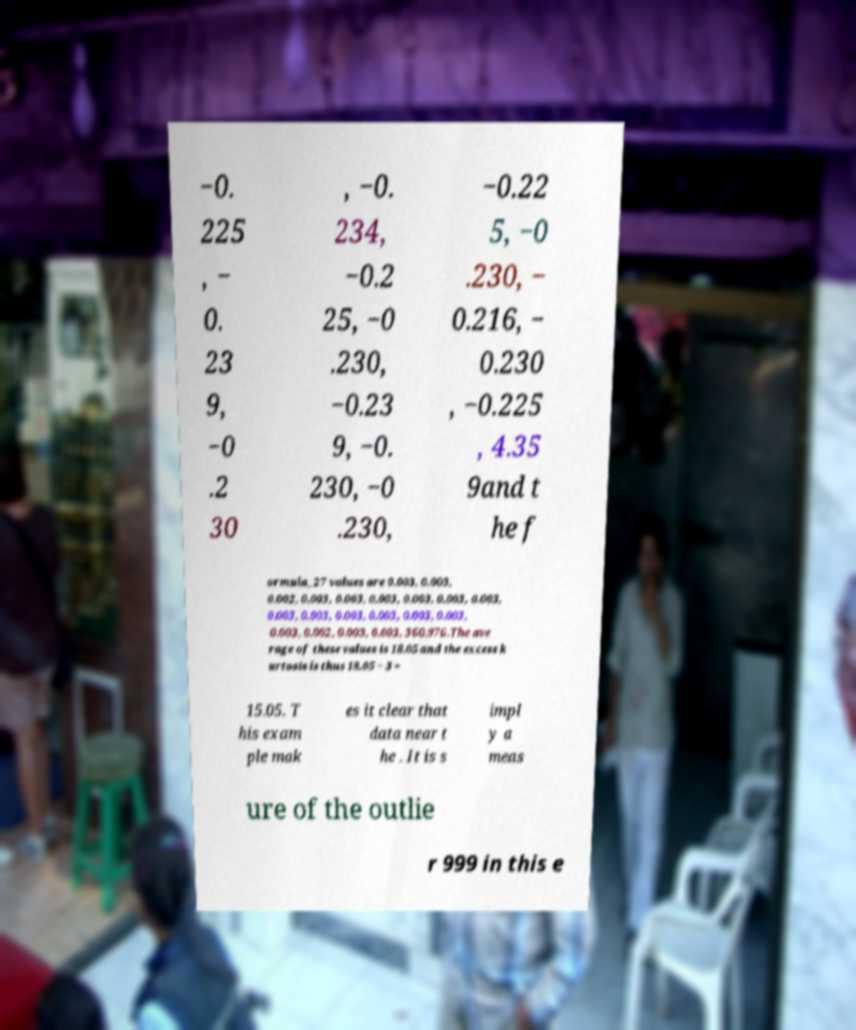For documentation purposes, I need the text within this image transcribed. Could you provide that? −0. 225 , − 0. 23 9, −0 .2 30 , −0. 234, −0.2 25, −0 .230, −0.23 9, −0. 230, −0 .230, −0.22 5, −0 .230, − 0.216, − 0.230 , −0.225 , 4.35 9and t he f ormula_27 values are 0.003, 0.003, 0.002, 0.003, 0.003, 0.003, 0.003, 0.003, 0.003, 0.003, 0.003, 0.003, 0.003, 0.003, 0.003, 0.003, 0.002, 0.003, 0.003, 360.976.The ave rage of these values is 18.05 and the excess k urtosis is thus 18.05 − 3 = 15.05. T his exam ple mak es it clear that data near t he . It is s impl y a meas ure of the outlie r 999 in this e 